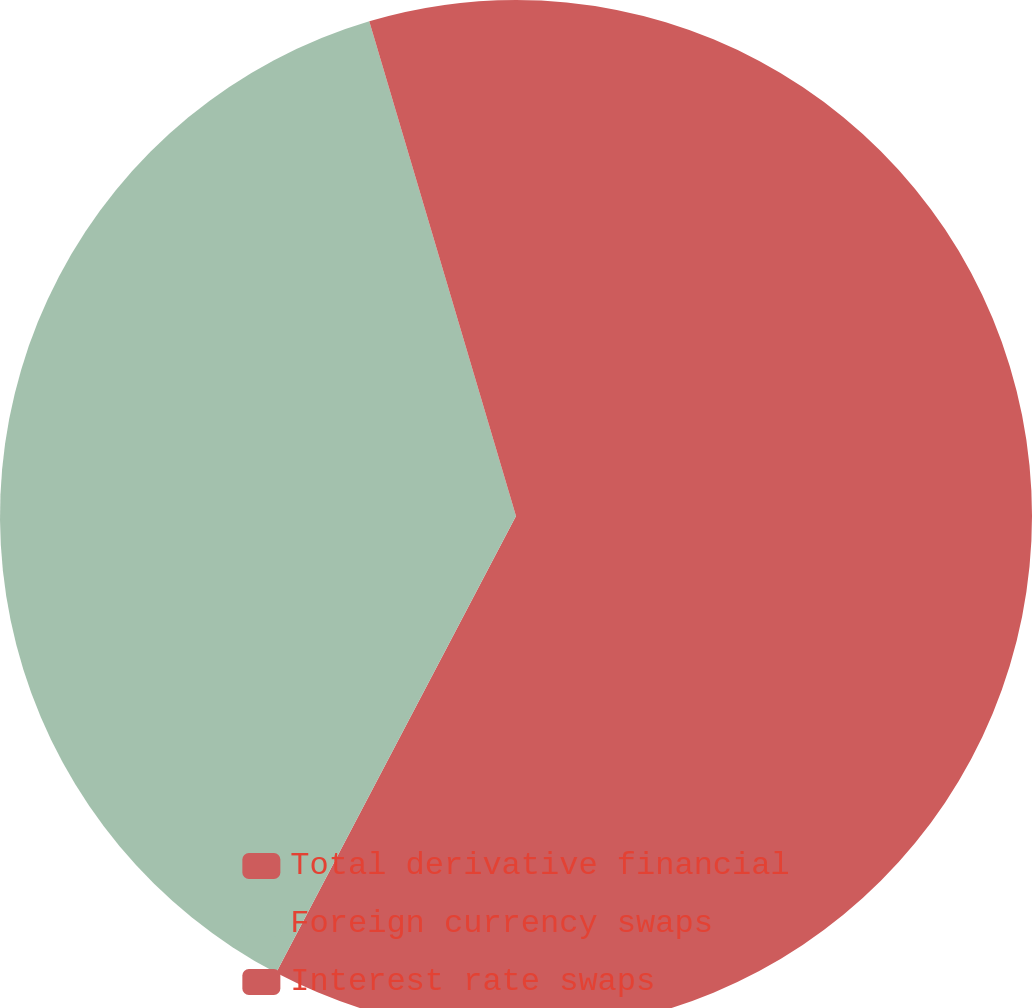Convert chart to OTSL. <chart><loc_0><loc_0><loc_500><loc_500><pie_chart><fcel>Total derivative financial<fcel>Foreign currency swaps<fcel>Interest rate swaps<nl><fcel>57.7%<fcel>37.72%<fcel>4.59%<nl></chart> 